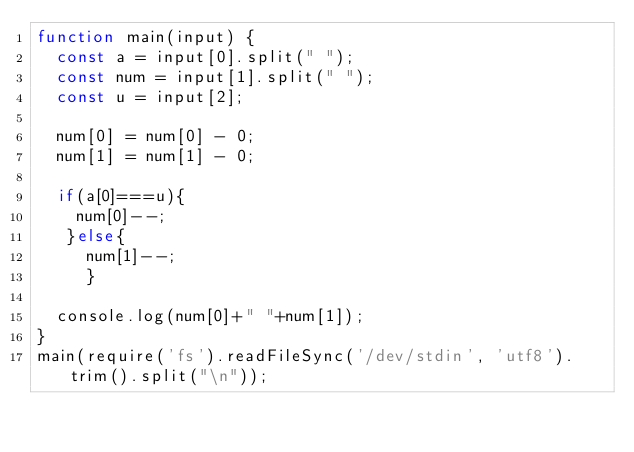<code> <loc_0><loc_0><loc_500><loc_500><_JavaScript_>function main(input) {
  const a = input[0].split(" ");
  const num = input[1].split(" ");
  const u = input[2];
  
  num[0] = num[0] - 0;
  num[1] = num[1] - 0;
  
  if(a[0]===u){
    num[0]--;
   }else{
     num[1]--;
     }
  
  console.log(num[0]+" "+num[1]);
}
main(require('fs').readFileSync('/dev/stdin', 'utf8').trim().split("\n"));</code> 